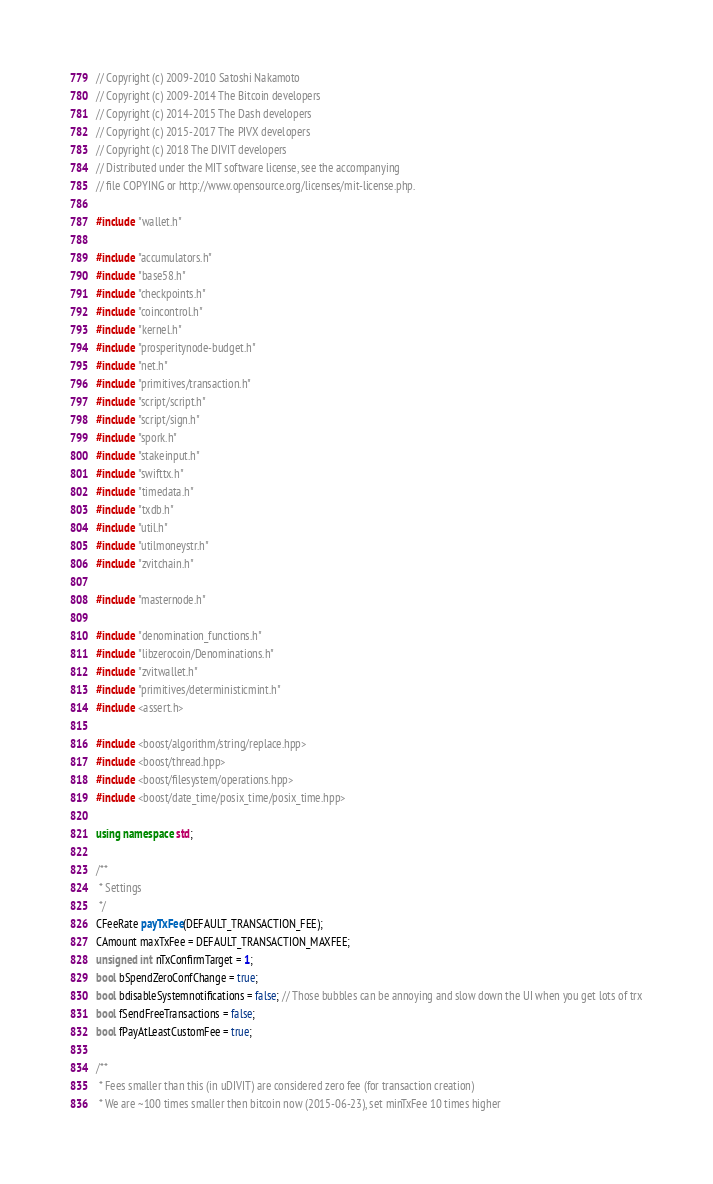<code> <loc_0><loc_0><loc_500><loc_500><_C++_>// Copyright (c) 2009-2010 Satoshi Nakamoto
// Copyright (c) 2009-2014 The Bitcoin developers
// Copyright (c) 2014-2015 The Dash developers
// Copyright (c) 2015-2017 The PIVX developers
// Copyright (c) 2018 The DIVIT developers
// Distributed under the MIT software license, see the accompanying
// file COPYING or http://www.opensource.org/licenses/mit-license.php.

#include "wallet.h"

#include "accumulators.h"
#include "base58.h"
#include "checkpoints.h"
#include "coincontrol.h"
#include "kernel.h"
#include "prosperitynode-budget.h"
#include "net.h"
#include "primitives/transaction.h"
#include "script/script.h"
#include "script/sign.h"
#include "spork.h"
#include "stakeinput.h"
#include "swifttx.h"
#include "timedata.h"
#include "txdb.h"
#include "util.h"
#include "utilmoneystr.h"
#include "zvitchain.h"

#include "masternode.h"

#include "denomination_functions.h"
#include "libzerocoin/Denominations.h"
#include "zvitwallet.h"
#include "primitives/deterministicmint.h"
#include <assert.h>

#include <boost/algorithm/string/replace.hpp>
#include <boost/thread.hpp>
#include <boost/filesystem/operations.hpp>
#include <boost/date_time/posix_time/posix_time.hpp>

using namespace std;

/**
 * Settings
 */
CFeeRate payTxFee(DEFAULT_TRANSACTION_FEE);
CAmount maxTxFee = DEFAULT_TRANSACTION_MAXFEE;
unsigned int nTxConfirmTarget = 1;
bool bSpendZeroConfChange = true;
bool bdisableSystemnotifications = false; // Those bubbles can be annoying and slow down the UI when you get lots of trx
bool fSendFreeTransactions = false;
bool fPayAtLeastCustomFee = true;

/**
 * Fees smaller than this (in uDIVIT) are considered zero fee (for transaction creation)
 * We are ~100 times smaller then bitcoin now (2015-06-23), set minTxFee 10 times higher</code> 